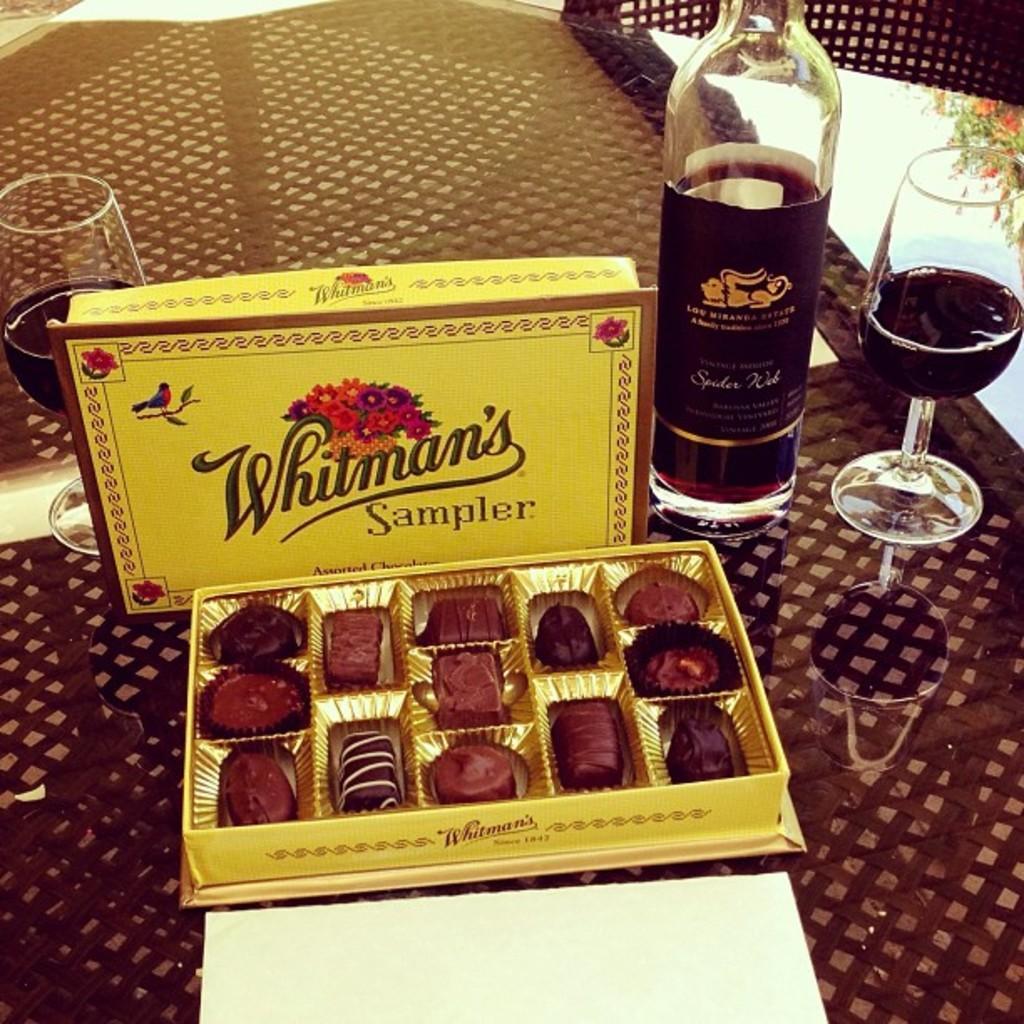Could you give a brief overview of what you see in this image? In this image I see a chocolate box, a bottle and 2 glasses. 